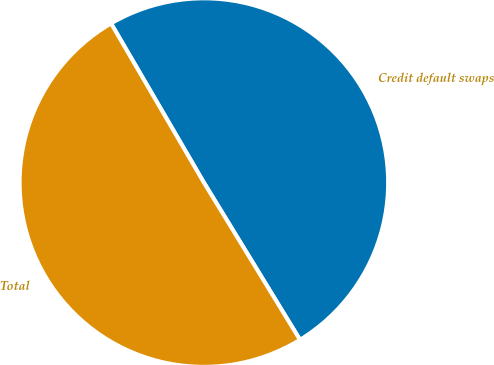Convert chart to OTSL. <chart><loc_0><loc_0><loc_500><loc_500><pie_chart><fcel>Credit default swaps<fcel>Total<nl><fcel>49.67%<fcel>50.33%<nl></chart> 